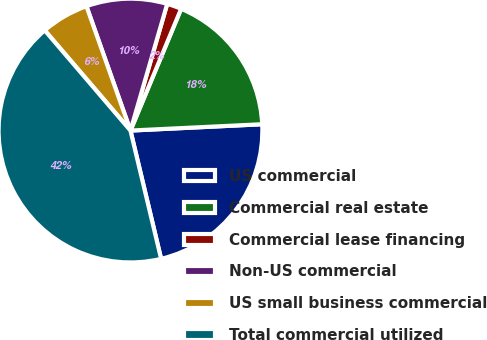Convert chart to OTSL. <chart><loc_0><loc_0><loc_500><loc_500><pie_chart><fcel>US commercial<fcel>Commercial real estate<fcel>Commercial lease financing<fcel>Non-US commercial<fcel>US small business commercial<fcel>Total commercial utilized<nl><fcel>22.03%<fcel>17.96%<fcel>1.78%<fcel>9.91%<fcel>5.85%<fcel>42.47%<nl></chart> 